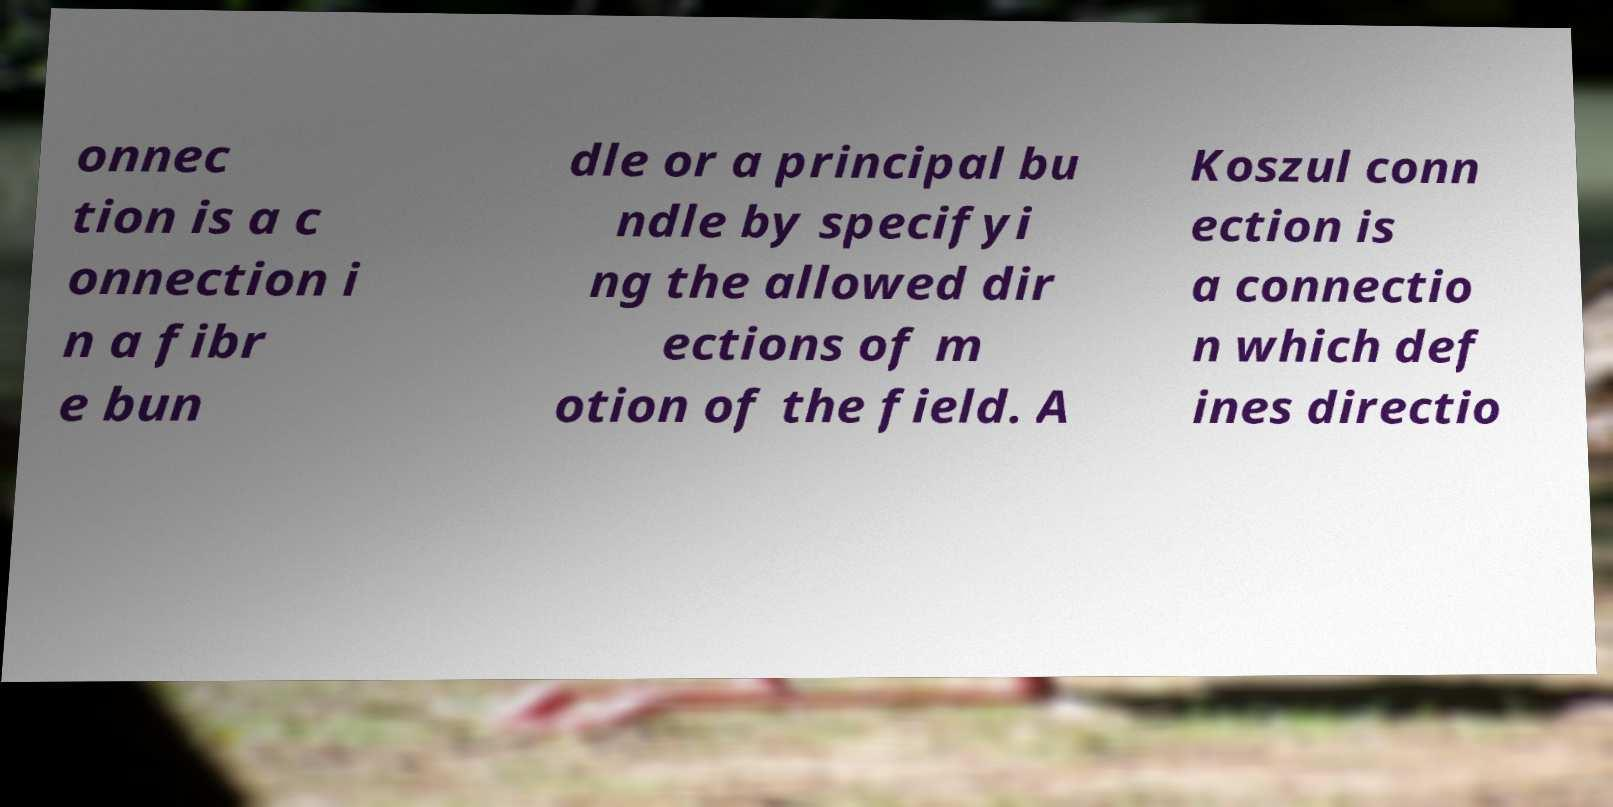Can you accurately transcribe the text from the provided image for me? onnec tion is a c onnection i n a fibr e bun dle or a principal bu ndle by specifyi ng the allowed dir ections of m otion of the field. A Koszul conn ection is a connectio n which def ines directio 